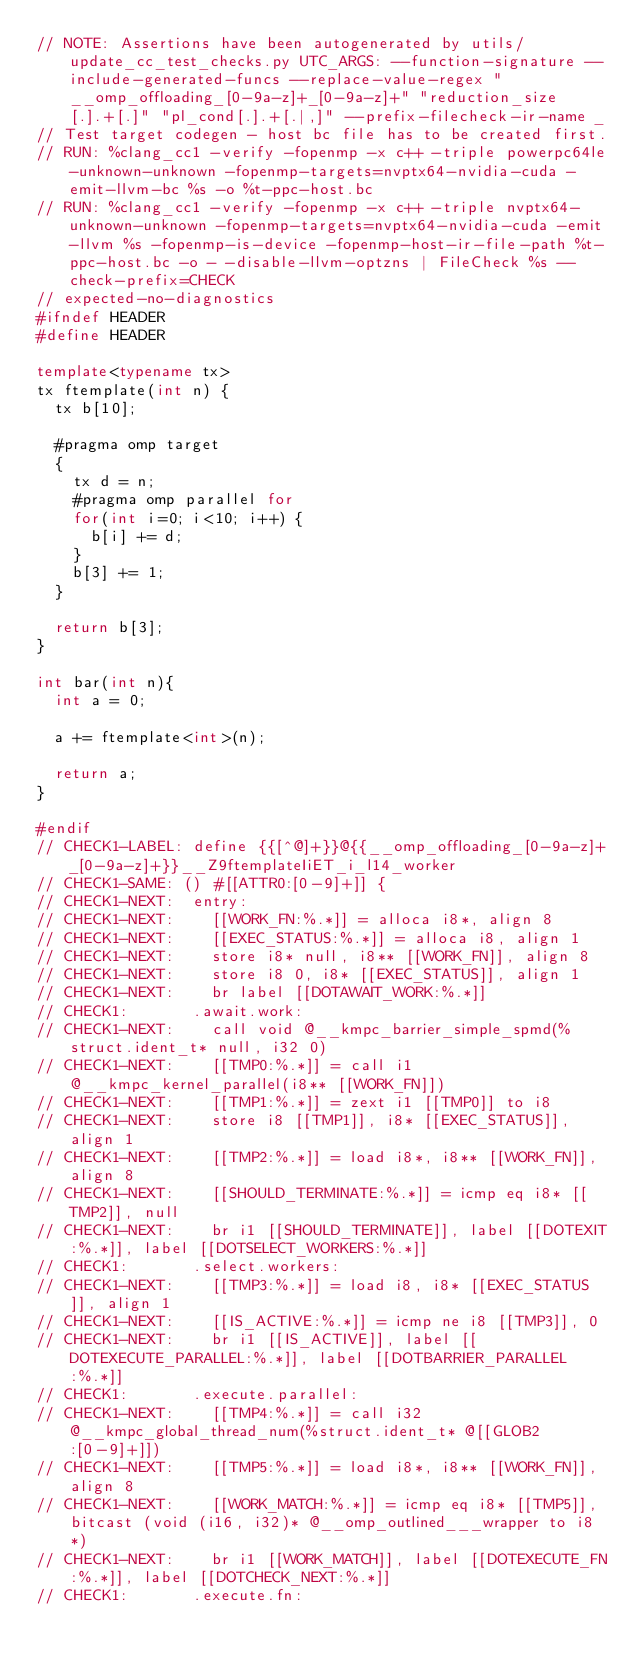Convert code to text. <code><loc_0><loc_0><loc_500><loc_500><_C++_>// NOTE: Assertions have been autogenerated by utils/update_cc_test_checks.py UTC_ARGS: --function-signature --include-generated-funcs --replace-value-regex "__omp_offloading_[0-9a-z]+_[0-9a-z]+" "reduction_size[.].+[.]" "pl_cond[.].+[.|,]" --prefix-filecheck-ir-name _
// Test target codegen - host bc file has to be created first.
// RUN: %clang_cc1 -verify -fopenmp -x c++ -triple powerpc64le-unknown-unknown -fopenmp-targets=nvptx64-nvidia-cuda -emit-llvm-bc %s -o %t-ppc-host.bc
// RUN: %clang_cc1 -verify -fopenmp -x c++ -triple nvptx64-unknown-unknown -fopenmp-targets=nvptx64-nvidia-cuda -emit-llvm %s -fopenmp-is-device -fopenmp-host-ir-file-path %t-ppc-host.bc -o - -disable-llvm-optzns | FileCheck %s --check-prefix=CHECK
// expected-no-diagnostics
#ifndef HEADER
#define HEADER

template<typename tx>
tx ftemplate(int n) {
  tx b[10];

  #pragma omp target
  {
    tx d = n;
    #pragma omp parallel for
    for(int i=0; i<10; i++) {
      b[i] += d;
    }
    b[3] += 1;
  }

  return b[3];
}

int bar(int n){
  int a = 0;

  a += ftemplate<int>(n);

  return a;
}

#endif
// CHECK1-LABEL: define {{[^@]+}}@{{__omp_offloading_[0-9a-z]+_[0-9a-z]+}}__Z9ftemplateIiET_i_l14_worker
// CHECK1-SAME: () #[[ATTR0:[0-9]+]] {
// CHECK1-NEXT:  entry:
// CHECK1-NEXT:    [[WORK_FN:%.*]] = alloca i8*, align 8
// CHECK1-NEXT:    [[EXEC_STATUS:%.*]] = alloca i8, align 1
// CHECK1-NEXT:    store i8* null, i8** [[WORK_FN]], align 8
// CHECK1-NEXT:    store i8 0, i8* [[EXEC_STATUS]], align 1
// CHECK1-NEXT:    br label [[DOTAWAIT_WORK:%.*]]
// CHECK1:       .await.work:
// CHECK1-NEXT:    call void @__kmpc_barrier_simple_spmd(%struct.ident_t* null, i32 0)
// CHECK1-NEXT:    [[TMP0:%.*]] = call i1 @__kmpc_kernel_parallel(i8** [[WORK_FN]])
// CHECK1-NEXT:    [[TMP1:%.*]] = zext i1 [[TMP0]] to i8
// CHECK1-NEXT:    store i8 [[TMP1]], i8* [[EXEC_STATUS]], align 1
// CHECK1-NEXT:    [[TMP2:%.*]] = load i8*, i8** [[WORK_FN]], align 8
// CHECK1-NEXT:    [[SHOULD_TERMINATE:%.*]] = icmp eq i8* [[TMP2]], null
// CHECK1-NEXT:    br i1 [[SHOULD_TERMINATE]], label [[DOTEXIT:%.*]], label [[DOTSELECT_WORKERS:%.*]]
// CHECK1:       .select.workers:
// CHECK1-NEXT:    [[TMP3:%.*]] = load i8, i8* [[EXEC_STATUS]], align 1
// CHECK1-NEXT:    [[IS_ACTIVE:%.*]] = icmp ne i8 [[TMP3]], 0
// CHECK1-NEXT:    br i1 [[IS_ACTIVE]], label [[DOTEXECUTE_PARALLEL:%.*]], label [[DOTBARRIER_PARALLEL:%.*]]
// CHECK1:       .execute.parallel:
// CHECK1-NEXT:    [[TMP4:%.*]] = call i32 @__kmpc_global_thread_num(%struct.ident_t* @[[GLOB2:[0-9]+]])
// CHECK1-NEXT:    [[TMP5:%.*]] = load i8*, i8** [[WORK_FN]], align 8
// CHECK1-NEXT:    [[WORK_MATCH:%.*]] = icmp eq i8* [[TMP5]], bitcast (void (i16, i32)* @__omp_outlined___wrapper to i8*)
// CHECK1-NEXT:    br i1 [[WORK_MATCH]], label [[DOTEXECUTE_FN:%.*]], label [[DOTCHECK_NEXT:%.*]]
// CHECK1:       .execute.fn:</code> 